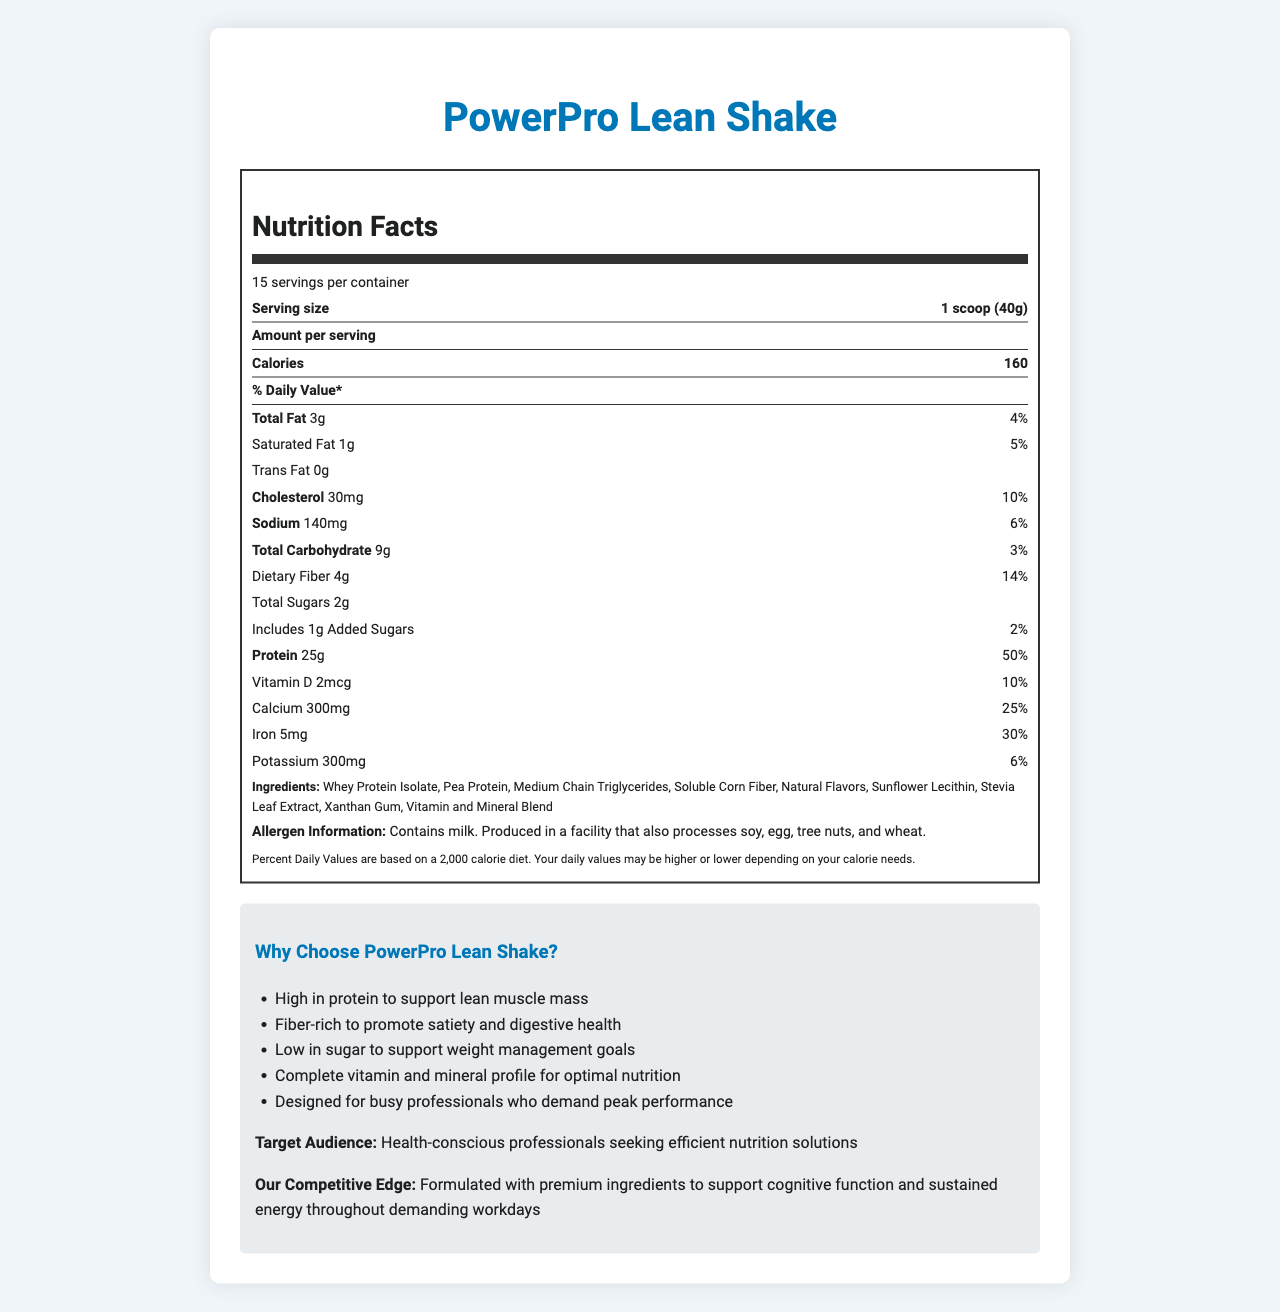what is the serving size for PowerPro Lean Shake? Serving size is explicitly stated in the document.
Answer: 1 scoop (40g) how many servings are in a container? The document specifies that there are 15 servings per container.
Answer: 15 how many calories does one serving contain? The document mentions that each serving contains 160 calories.
Answer: 160 what is the amount of protein in one serving? The protein content per serving is stated as 25g.
Answer: 25g what is the daily value percentage for cholesterol? The daily value percentage for cholesterol is provided as 10%.
Answer: 10% what ingredients are in PowerPro Lean Shake? These ingredients are listed under the ingredients section of the document.
Answer: Whey Protein Isolate, Pea Protein, Medium Chain Triglycerides, Soluble Corn Fiber, Natural Flavors, Sunflower Lecithin, Stevia Leaf Extract, Xanthan Gum, Vitamin and Mineral Blend which vitamin in PowerPro Lean Shake has the highest percentage of daily value? All these vitamins and minerals have a daily value percentage of 50%, as indicated in the document.
Answer: Vitamin A, Vitamin C, Vitamin E, Vitamin K, Thiamin, Riboflavin, Niacin, Vitamin B6, Folate, Vitamin B12, Biotin, Pantothenic Acid, Iodine, Zinc, Selenium, Copper, Manganese, Chromium, Molybdenum all have 50% what are the possible allergens mentioned? The allergen information section mentions these allergens.
Answer: Milk, soy, egg, tree nuts, wheat how much dietary fiber is in one serving? The document lists the amount of dietary fiber as 4g per serving.
Answer: 4g how should PowerPro Lean Shake be stored? The storage instructions are provided in the document.
Answer: Store in a cool, dry place. Refrigerate after opening. what is the target audience for PowerPro Lean Shake? A. Children B. Health-conscious professionals C. Athletes D. Elderly The target audience is explicitly mentioned as health-conscious professionals.
Answer: B. Health-conscious professionals what is the competitive edge of PowerPro Lean Shake? A. Low cost B. Great taste C. Premium ingredients D. Easy availability The document states that the competitive edge is formulated with premium ingredients.
Answer: C. Premium ingredients is PowerPro Lean Shake high in protein? The document makes it clear that the product is high in protein, containing 25g per serving.
Answer: Yes summarize the main idea of the document. The document gives a comprehensive overview of the nutritional value, ingredients, and benefits of PowerPro Lean Shake, emphasizing its suitability for health-conscious professionals.
Answer: The document provides detailed information about PowerPro Lean Shake, a protein-rich meal replacement designed for weight management. It includes nutritional facts, ingredients, allergen information, storage directions, and marketing claims targeted at busy, health-conscious professionals seeking optimal nutrition. The shake is formulated with premium ingredients to support lean muscle mass, satiety, digestive health, and sustained energy. can I find the price of PowerPro Lean Shake in this document? The document does not provide any information about the price of the product.
Answer: Not enough information 